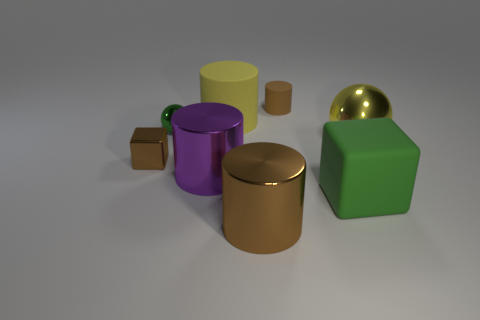There is a big metal object that is right of the brown thing behind the yellow sphere; how many brown matte cylinders are in front of it?
Ensure brevity in your answer.  0. There is a brown shiny object that is on the left side of the tiny shiny ball; what is its size?
Give a very brief answer. Small. How many blocks are the same size as the brown matte cylinder?
Provide a short and direct response. 1. There is a yellow rubber thing; does it have the same size as the ball that is on the right side of the large purple object?
Your answer should be very brief. Yes. What number of things are yellow matte cylinders or metallic cylinders?
Keep it short and to the point. 3. What number of small metallic things have the same color as the big rubber cylinder?
Make the answer very short. 0. There is a brown rubber object that is the same size as the green metallic ball; what shape is it?
Your answer should be very brief. Cylinder. Are there any large cyan metallic objects of the same shape as the green metallic object?
Provide a short and direct response. No. What number of small red things have the same material as the purple cylinder?
Offer a terse response. 0. Is the green object on the left side of the brown matte object made of the same material as the tiny block?
Make the answer very short. Yes. 